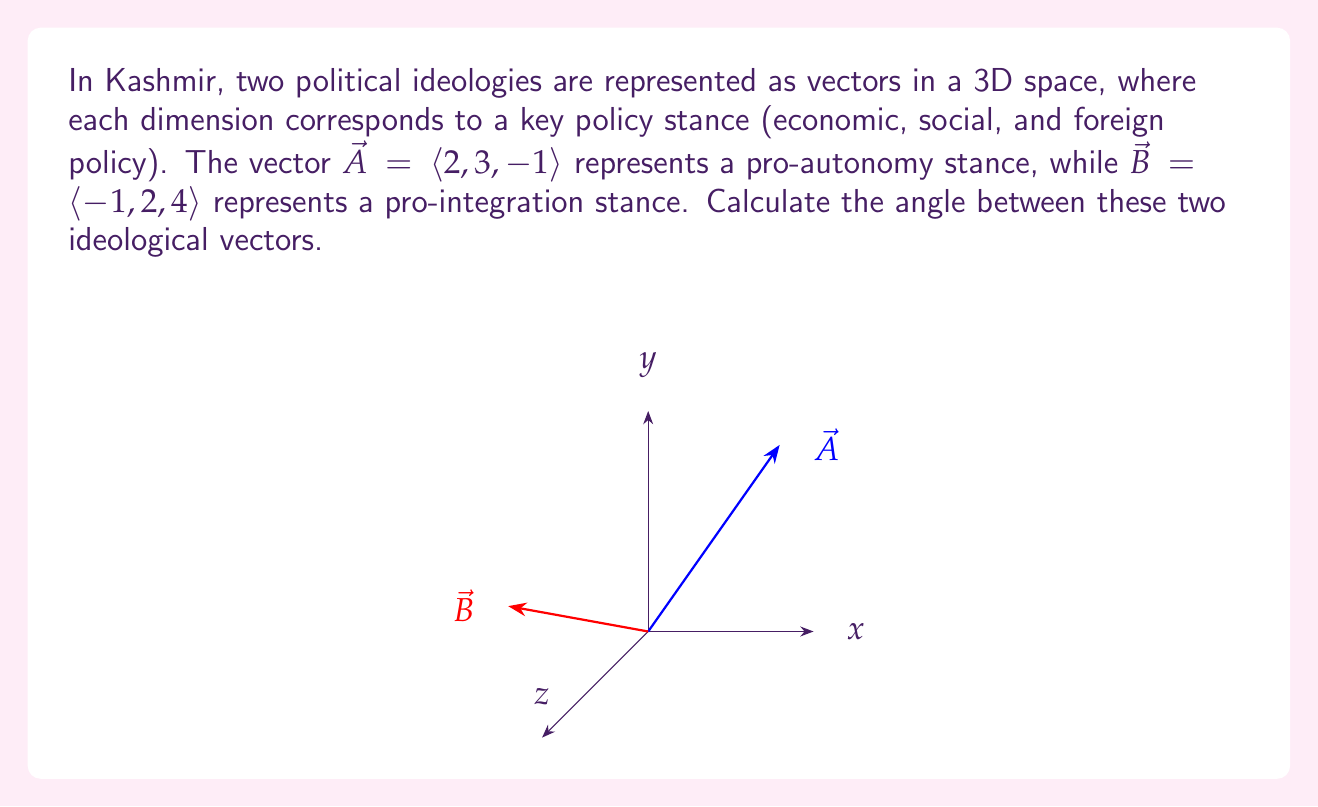Solve this math problem. To find the angle between two vectors, we can use the dot product formula:

$$\cos \theta = \frac{\vec{A} \cdot \vec{B}}{|\vec{A}||\vec{B}|}$$

Step 1: Calculate the dot product $\vec{A} \cdot \vec{B}$
$$\vec{A} \cdot \vec{B} = (2)(-1) + (3)(2) + (-1)(4) = -2 + 6 - 4 = 0$$

Step 2: Calculate the magnitudes of $\vec{A}$ and $\vec{B}$
$$|\vec{A}| = \sqrt{2^2 + 3^2 + (-1)^2} = \sqrt{4 + 9 + 1} = \sqrt{14}$$
$$|\vec{B}| = \sqrt{(-1)^2 + 2^2 + 4^2} = \sqrt{1 + 4 + 16} = \sqrt{21}$$

Step 3: Substitute into the formula
$$\cos \theta = \frac{0}{\sqrt{14}\sqrt{21}} = 0$$

Step 4: Solve for $\theta$
$$\theta = \arccos(0) = 90°$$

This result indicates that the two political ideologies are orthogonal, meaning they are completely independent of each other in this representation.
Answer: $90°$ 